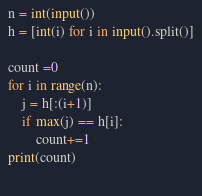<code> <loc_0><loc_0><loc_500><loc_500><_Python_>n = int(input())
h = [int(i) for i in input().split()]

count =0 
for i in range(n):
    j = h[:(i+1)]
    if max(j) == h[i]:
        count+=1
print(count)
            </code> 